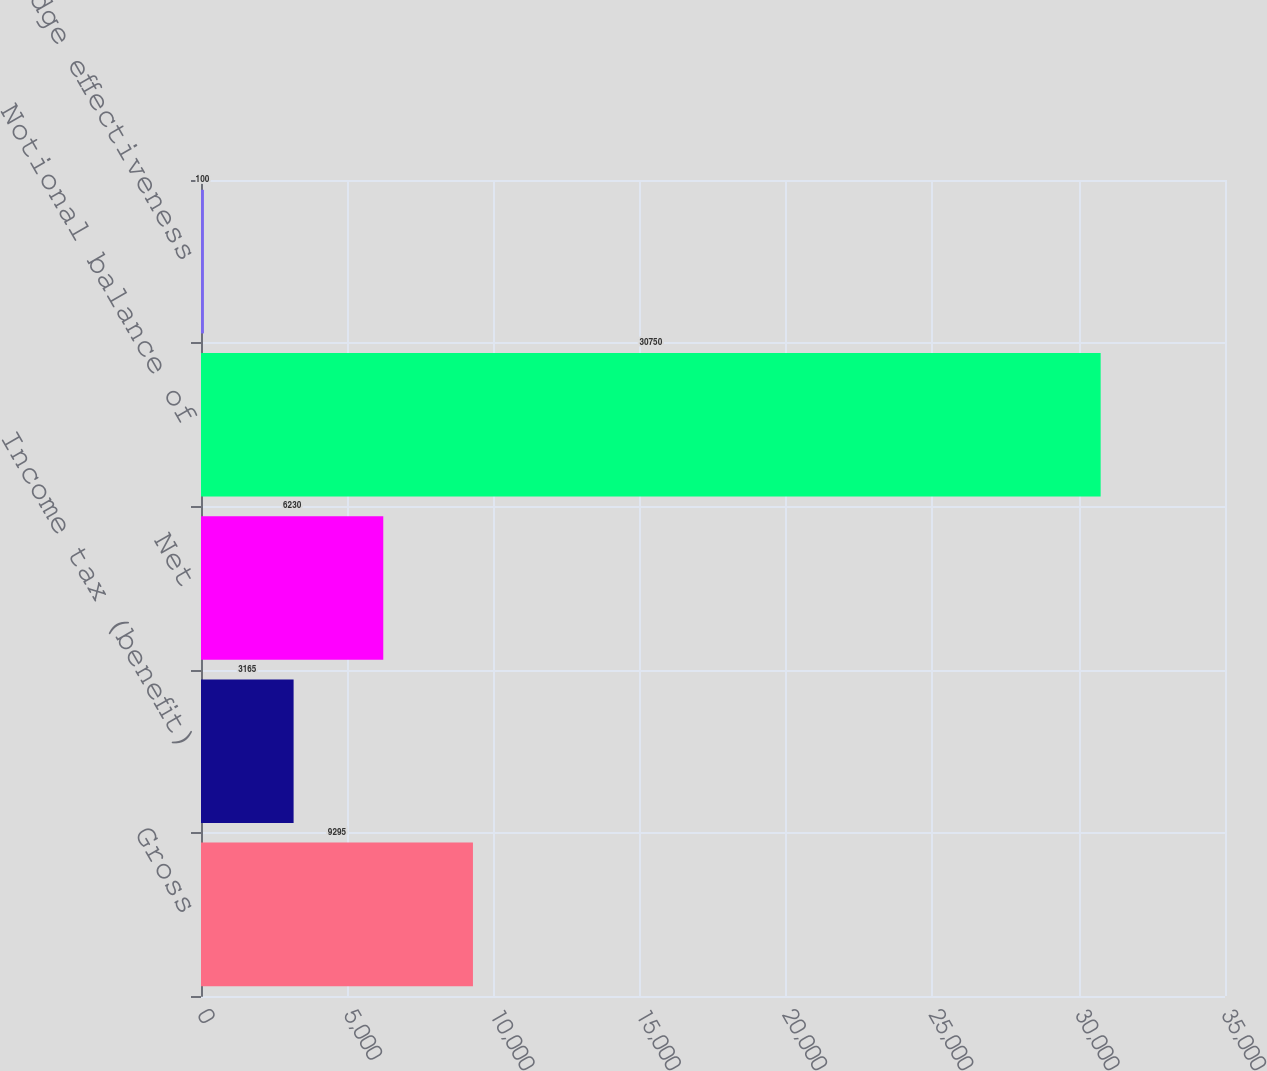Convert chart to OTSL. <chart><loc_0><loc_0><loc_500><loc_500><bar_chart><fcel>Gross<fcel>Income tax (benefit)<fcel>Net<fcel>Notional balance of<fcel>Hedge effectiveness<nl><fcel>9295<fcel>3165<fcel>6230<fcel>30750<fcel>100<nl></chart> 